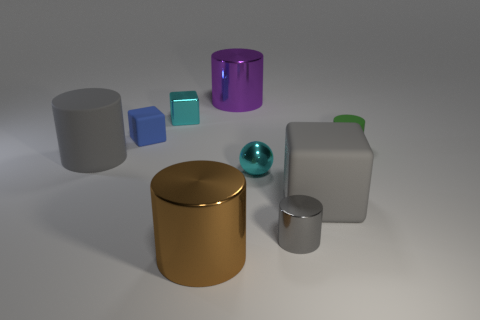Subtract all purple cylinders. How many cylinders are left? 4 Subtract all blue cylinders. Subtract all cyan blocks. How many cylinders are left? 5 Add 1 purple objects. How many objects exist? 10 Subtract all cubes. How many objects are left? 6 Add 7 brown objects. How many brown objects exist? 8 Subtract 1 cyan cubes. How many objects are left? 8 Subtract all big metallic things. Subtract all large cubes. How many objects are left? 6 Add 3 gray cubes. How many gray cubes are left? 4 